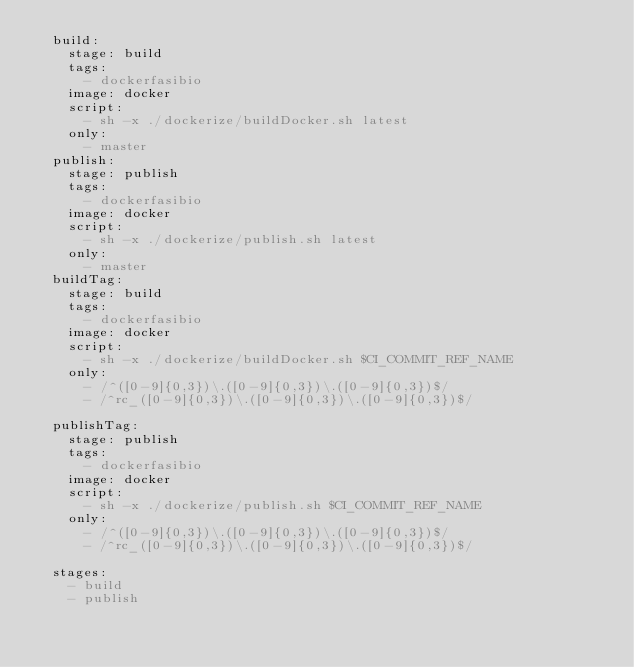Convert code to text. <code><loc_0><loc_0><loc_500><loc_500><_YAML_>  build:
    stage: build
    tags: 
      - dockerfasibio
    image: docker
    script:
      - sh -x ./dockerize/buildDocker.sh latest
    only:
      - master
  publish:
    stage: publish
    tags: 
      - dockerfasibio
    image: docker
    script:
      - sh -x ./dockerize/publish.sh latest
    only:
      - master
  buildTag:
    stage: build
    tags: 
      - dockerfasibio
    image: docker
    script:
      - sh -x ./dockerize/buildDocker.sh $CI_COMMIT_REF_NAME
    only:
      - /^([0-9]{0,3})\.([0-9]{0,3})\.([0-9]{0,3})$/
      - /^rc_([0-9]{0,3})\.([0-9]{0,3})\.([0-9]{0,3})$/
    
  publishTag:
    stage: publish
    tags: 
      - dockerfasibio
    image: docker
    script:
      - sh -x ./dockerize/publish.sh $CI_COMMIT_REF_NAME
    only:
      - /^([0-9]{0,3})\.([0-9]{0,3})\.([0-9]{0,3})$/
      - /^rc_([0-9]{0,3})\.([0-9]{0,3})\.([0-9]{0,3})$/

  stages: 
    - build
    - publish</code> 